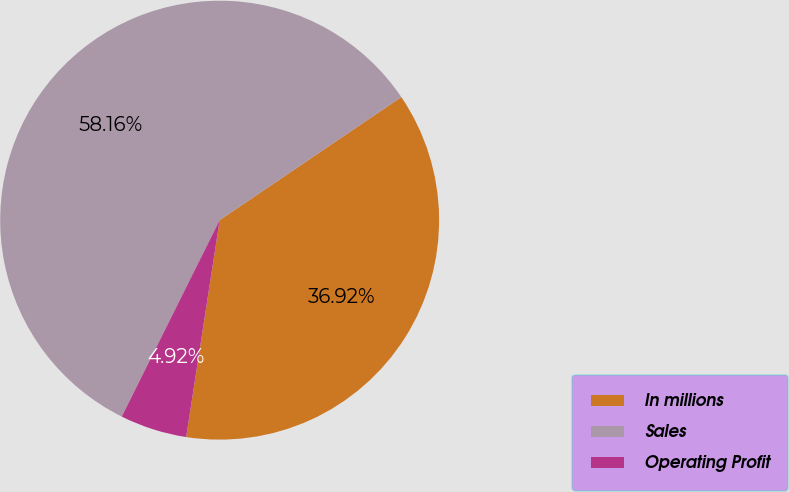<chart> <loc_0><loc_0><loc_500><loc_500><pie_chart><fcel>In millions<fcel>Sales<fcel>Operating Profit<nl><fcel>36.92%<fcel>58.17%<fcel>4.92%<nl></chart> 